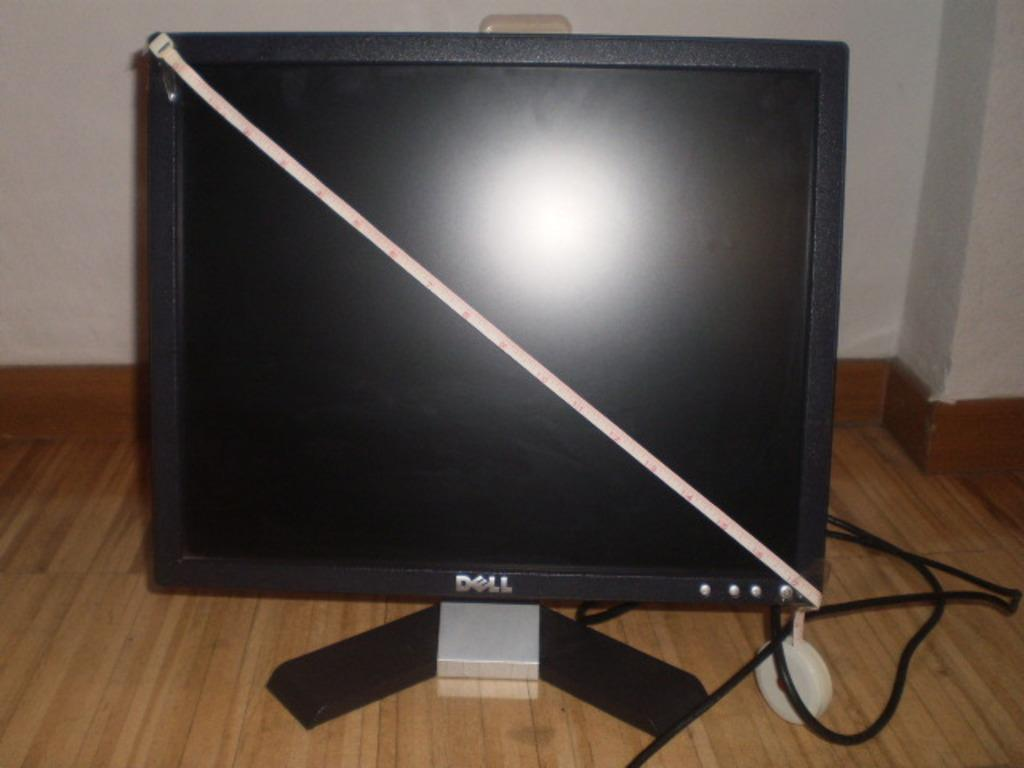<image>
Present a compact description of the photo's key features. A Dell monitor has a measuring tape going diagonally across the screen. 